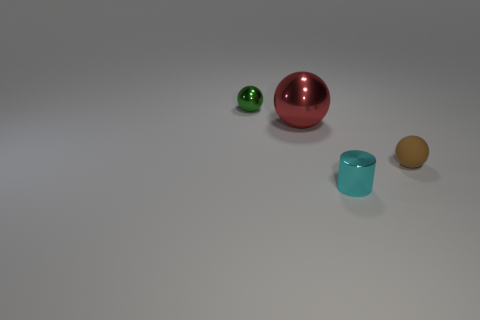Subtract all small brown balls. How many balls are left? 2 Add 2 red things. How many objects exist? 6 Subtract all balls. How many objects are left? 1 Subtract all brown spheres. How many spheres are left? 2 Add 3 small cyan shiny objects. How many small cyan shiny objects are left? 4 Add 2 red metallic spheres. How many red metallic spheres exist? 3 Subtract 0 purple cylinders. How many objects are left? 4 Subtract all yellow spheres. Subtract all blue cylinders. How many spheres are left? 3 Subtract all large blue metal cubes. Subtract all brown rubber objects. How many objects are left? 3 